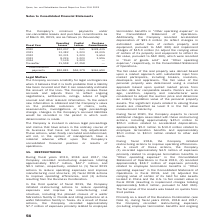From Qorvo's financial document, What are the company's respective operating leases and capital leases in 2020? The document shows two values: $22,207 and $241 (in thousands). From the document: "2020 $22,207 $ 241 $328,435 2021 13,382 1,220 24,005 2022 10,331 1,220 5,654 2023 8,224 1,220 3,596 2024 7,139 1,220 — 2020 $22,207 $ 241 $328,435 202..." Also, What are the company's respective operating leases and capital leases in 2021? The document shows two values: 13,382 and 1,220 (in thousands). From the document: "2020 $22,207 $ 241 $328,435 2021 13,382 1,220 24,005 2022 10,331 1,220 5,654 2023 8,224 1,220 3,596 2024 7,139 1,220 — Thereafter 31,598 47,258 — 2020..." Also, What are the company's respective operating leases and capital leases in 2022? The document shows two values: 10,331 and 1,220 (in thousands). From the document: ",207 $ 241 $328,435 2021 13,382 1,220 24,005 2022 10,331 1,220 5,654 2023 8,224 1,220 3,596 2024 7,139 1,220 — Thereafter 31,598 47,258 — 2020 $22,207..." Also, can you calculate: What is the company's total operating leases and capital leases in 2020? Based on the calculation: $22,207 + $241 , the result is 22448 (in thousands). This is based on the information: "2020 $22,207 $ 241 $328,435 2021 13,382 1,220 24,005 2022 10,331 1,220 5,654 2023 8,224 1,220 3,596 2024 7,139 1,220 — 2020 $22,207 $ 241 $328,435 2021 13,382 1,220 24,005 2022 10,331 1,220 5,654 2023..." The key data points involved are: 22,207, 241. Also, can you calculate: What is the company's average operating lease in 2020 and 2021? To answer this question, I need to perform calculations using the financial data. The calculation is: (22,207 + 13,382)/2 , which equals 17794.5 (in thousands). This is based on the information: "2020 $22,207 $ 241 $328,435 2021 13,382 1,220 24,005 2022 10,331 1,220 5,654 2023 8,224 1,220 3,596 2024 7,139 1 2020 $22,207 $ 241 $328,435 2021 13,382 1,220 24,005 2022 10,331 1,220 5,654 2023 8,224..." The key data points involved are: 13,382, 22,207. Also, can you calculate: What is the change in the company's operating leases in 2020 and 2021? Based on the calculation: 22,207 - 13,382 , the result is 8825 (in thousands). This is based on the information: "2020 $22,207 $ 241 $328,435 2021 13,382 1,220 24,005 2022 10,331 1,220 5,654 2023 8,224 1,220 3,596 2024 7,139 1 2020 $22,207 $ 241 $328,435 2021 13,382 1,220 24,005 2022 10,331 1,220 5,654 2023 8,224..." The key data points involved are: 13,382, 22,207. 